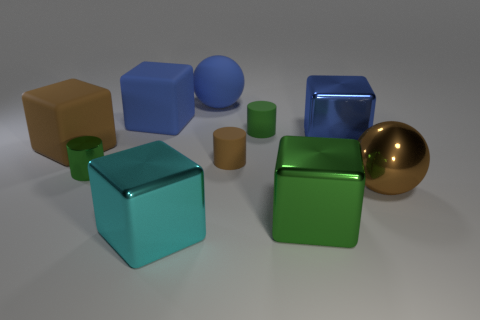Is the number of green things greater than the number of small green rubber cubes?
Provide a succinct answer. Yes. Is the blue cube that is on the right side of the green matte object made of the same material as the big brown cube?
Your answer should be very brief. No. Is the number of big green shiny objects less than the number of small matte cubes?
Your answer should be compact. No. Is there a blue block on the left side of the cylinder behind the blue object on the right side of the green metal cube?
Make the answer very short. Yes. Is the shape of the big brown object on the left side of the small brown object the same as  the tiny metal object?
Your response must be concise. No. Are there more tiny green matte objects behind the small brown rubber thing than tiny spheres?
Provide a succinct answer. Yes. There is a large cube that is right of the green cube; is its color the same as the big matte ball?
Ensure brevity in your answer.  Yes. Is there anything else that has the same color as the matte sphere?
Ensure brevity in your answer.  Yes. What is the color of the small matte cylinder in front of the brown thing that is on the left side of the tiny cylinder that is on the left side of the large cyan shiny block?
Your answer should be very brief. Brown. Is the blue ball the same size as the brown matte cylinder?
Make the answer very short. No. 